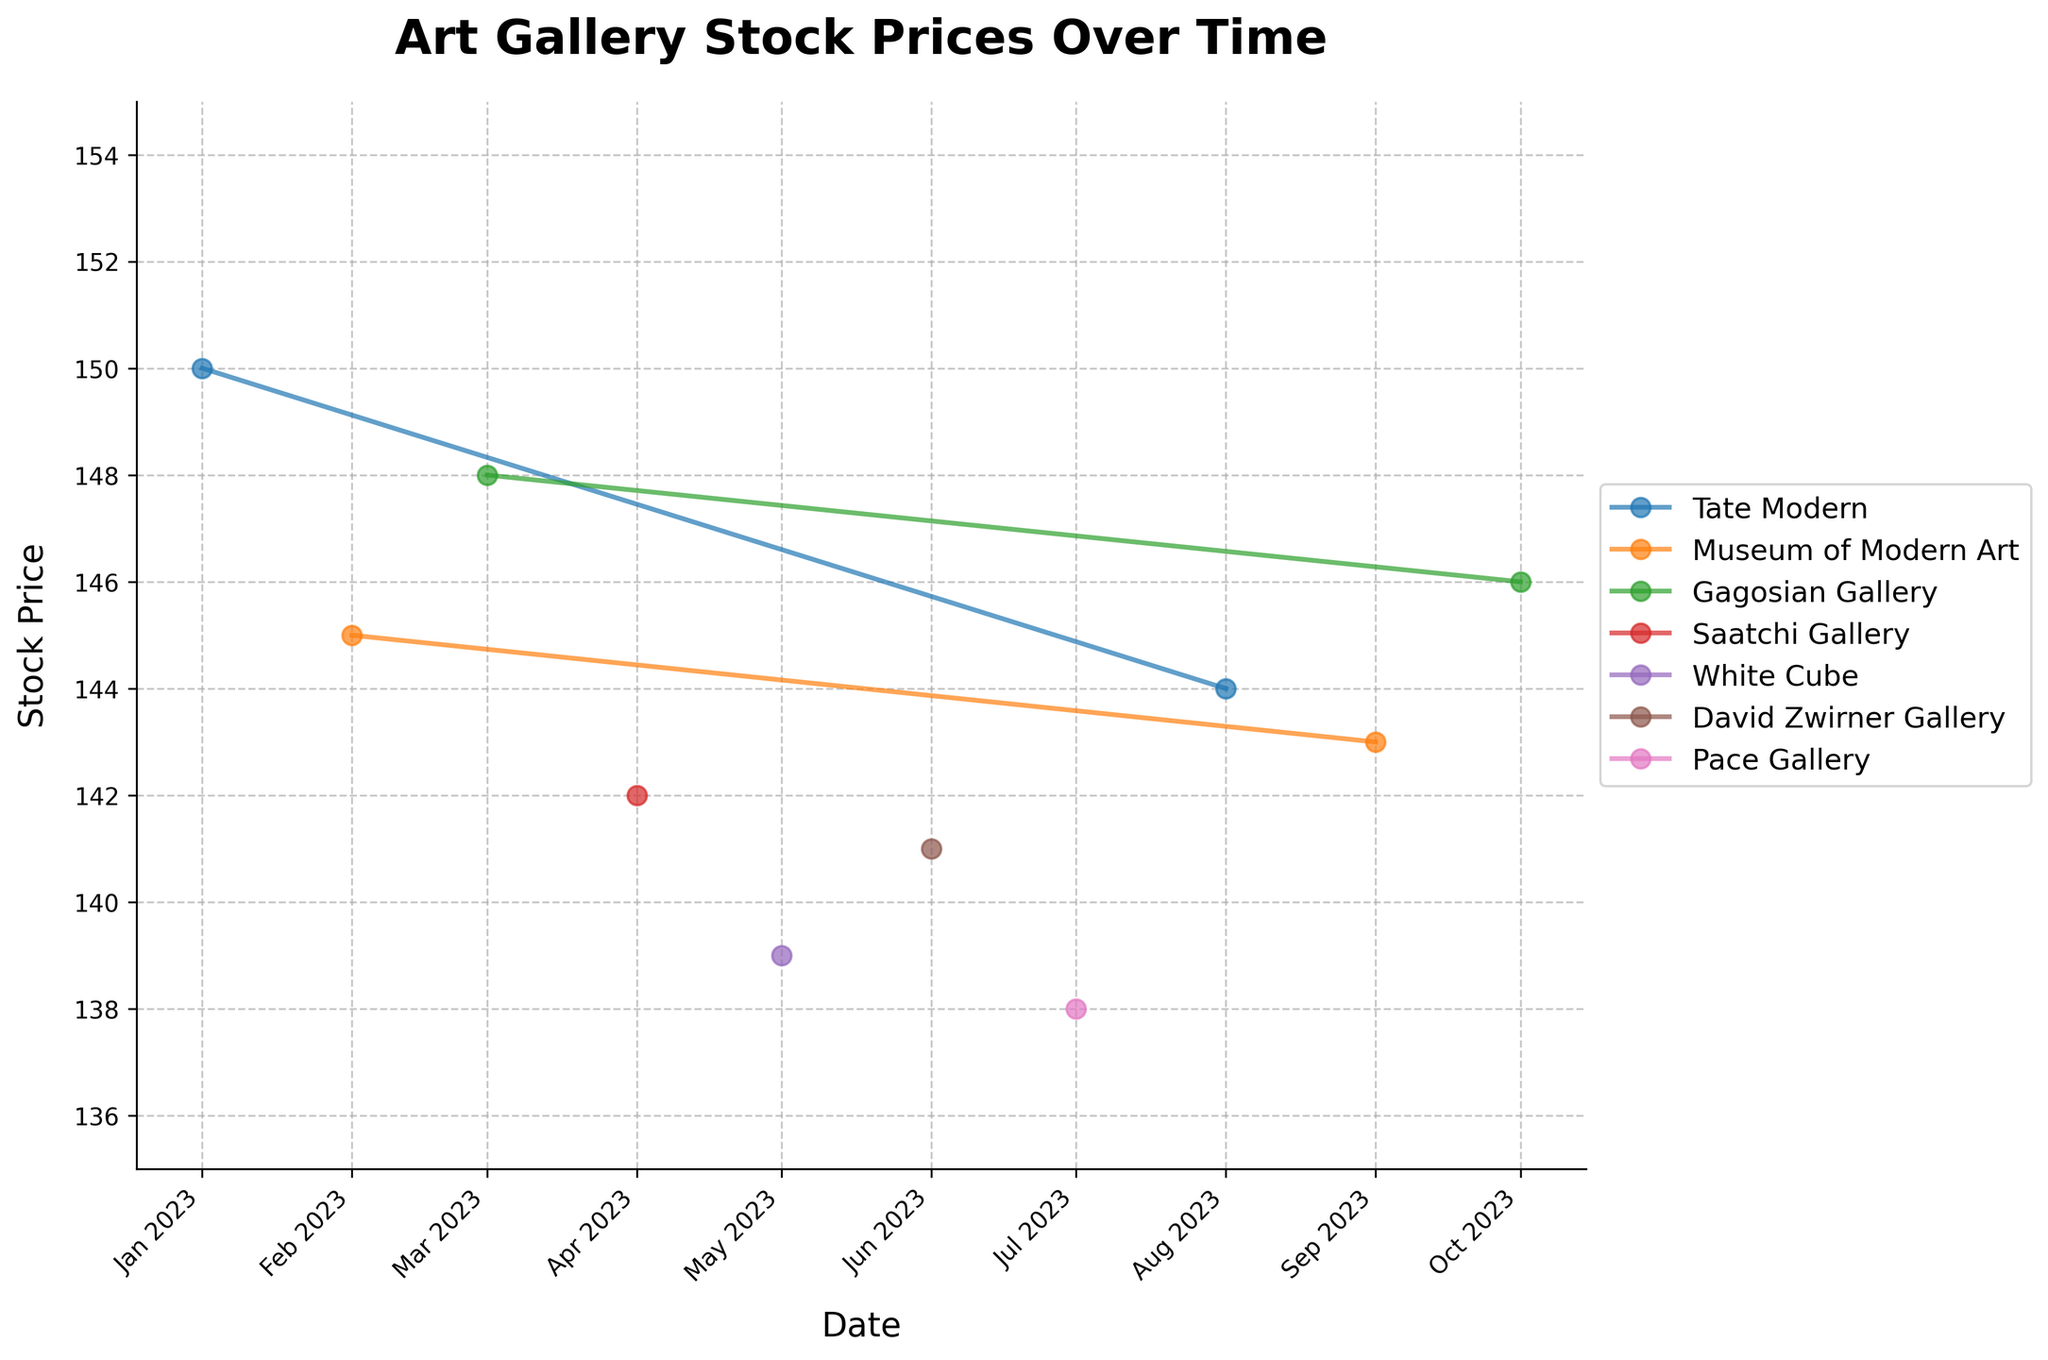What is the title of the plot? The title of the plot is at the top and is often the largest text in the figure, indicating the main topic being visualized. In this case, the title is "Art Gallery Stock Prices Over Time".
Answer: Art Gallery Stock Prices Over Time Which gallery has the highest stock price in October 2023? By looking at the end of the line for October 2023 and identifying the highest point, we can see Gagosian Gallery has the highest stock price at 146.
Answer: Gagosian Gallery What is the average stock price of Tate Modern throughout the displayed period? We need to sum the stock prices for Tate Modern in January and August (150 + 144) and divide by the number of occurrences (2): (150 + 144) / 2 = 147.
Answer: 147 Between which months did White Cube see the steepest decline in stock price? Observing the trend for White Cube, we see the steepest decline between April and May when the stock price dropped from 142 to 139.
Answer: April to May How does the stock price of Museum of Modern Art in September 2023 compare to its price in February 2023? Comparing the stock prices directly from February (145) and September (143), we see a slight decrease in the stock price: 145 - 143 = 2.
Answer: Decreased by 2 Which gallery experienced the most consistent stock price throughout the displayed period? By observing the lines representing each gallery, Tate Modern shows minimal fluctuation, maintaining prices close to 150 and 144 over January and August, indicating more consistency.
Answer: Tate Modern What was the range of the stock prices for David Zwirner Gallery? The range is calculated by subtracting the lowest stock price from the highest. For David Zwirner Gallery, prices ranged from 141 in June. The range is 141 - 141 = 0.
Answer: 0 Which month recorded the lowest stock price, and which gallery did it belong to? Looking at the lowest point on the plot, it occurred in July for Pace Gallery with a price of 138.
Answer: July, Pace Gallery 